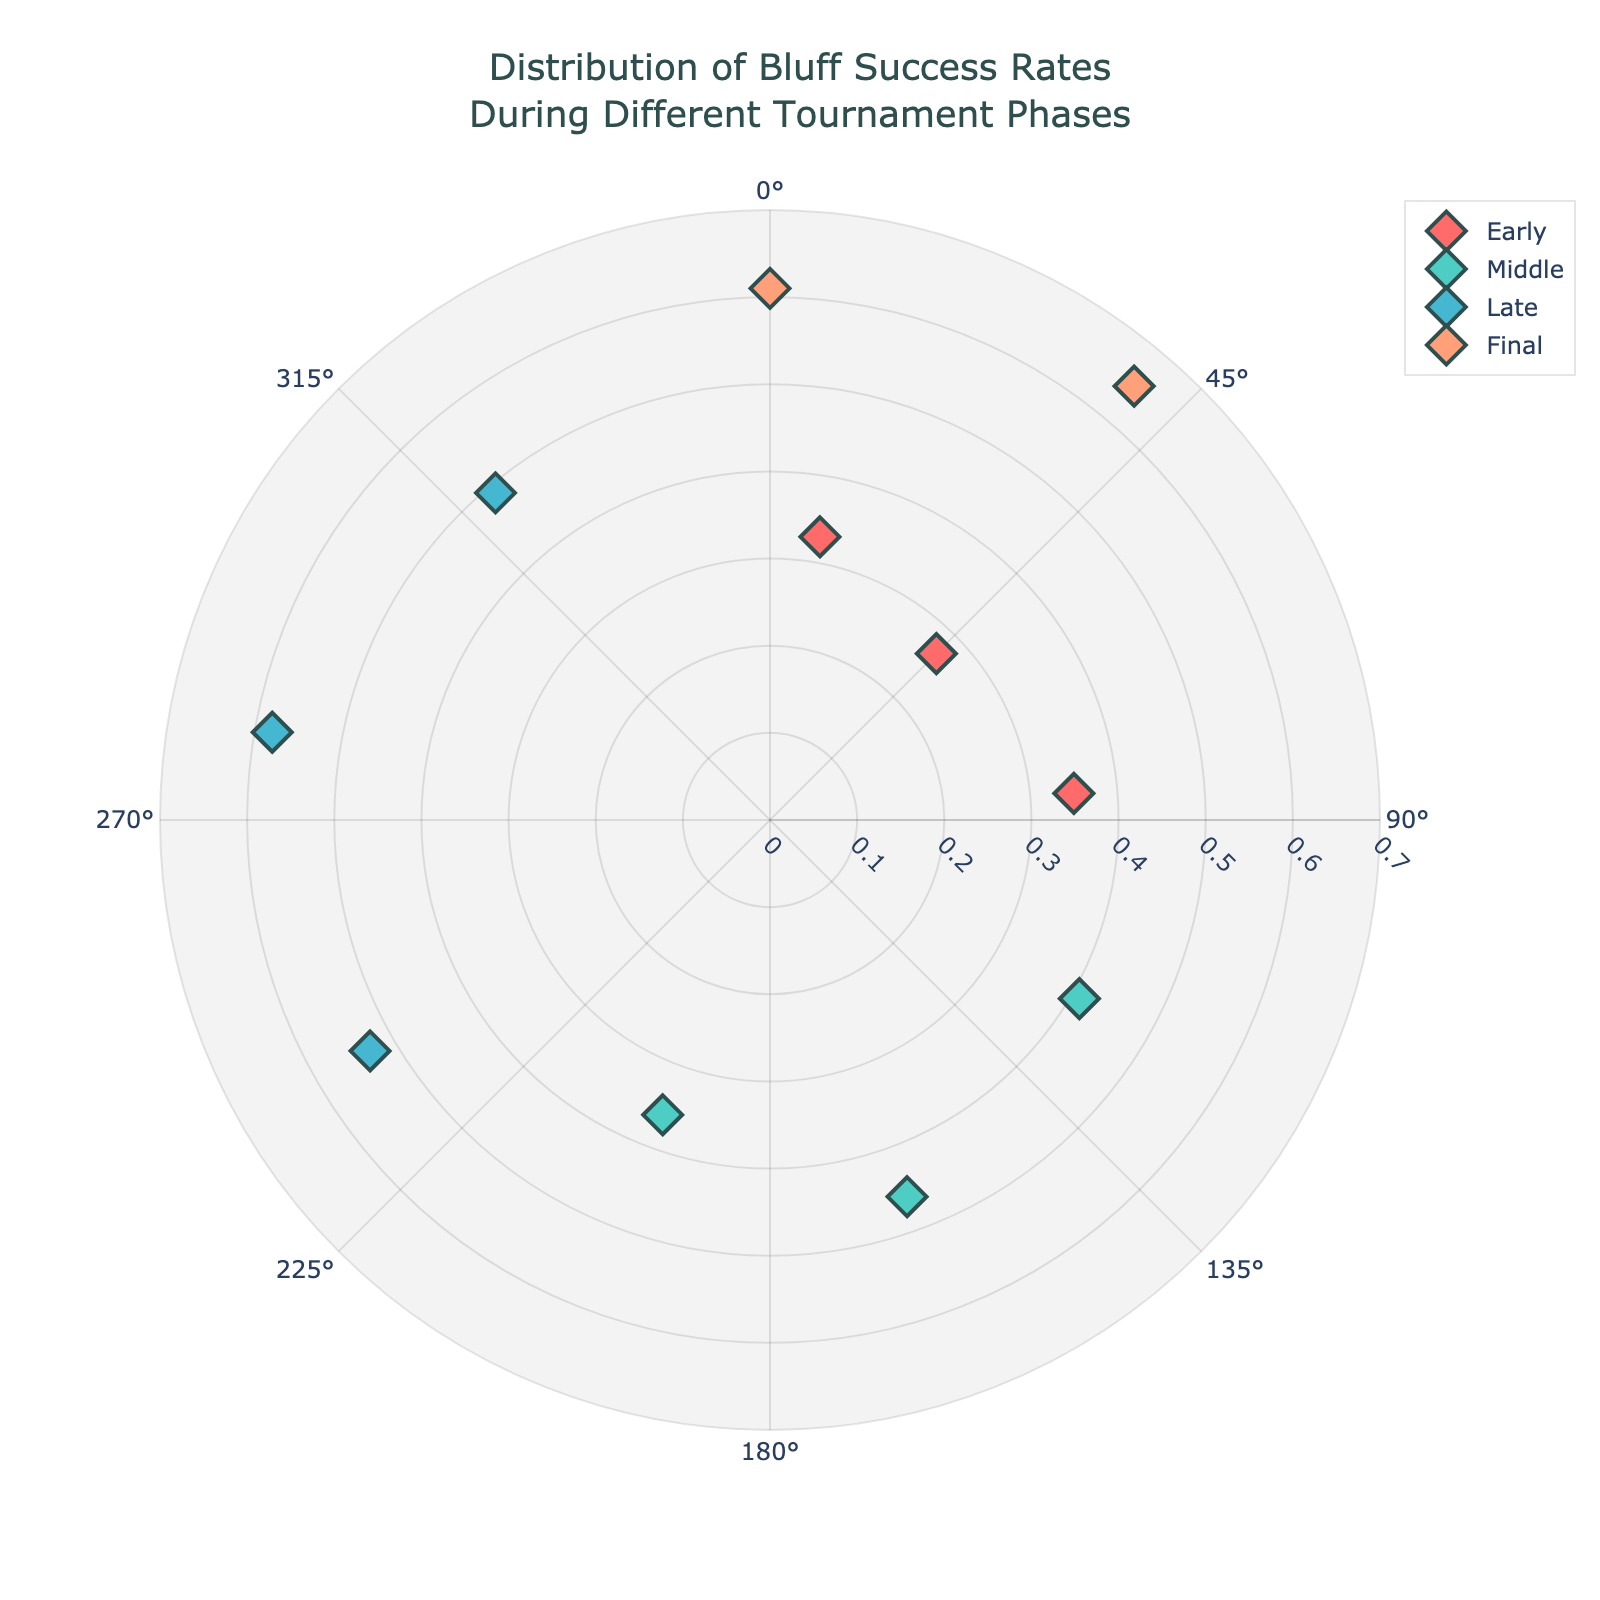what is the title of the chart? The title is located at the top of the chart and reads "Distribution of Bluff Success Rates During Different Tournament Phases".
Answer: Distribution of Bluff Success Rates During Different Tournament Phases how many different tournament phases are shown in the chart? By observing the legend on the chart, we see there are four distinct tournament phases indicated: Early, Middle, Late, and Final.
Answer: 4 which tournament phase has the highest bluff success rate? To determine the highest bluff success rate, we look at the furthest points from the center. The phase labeled "Final" has the most distant point from the center at a success rate of 0.65.
Answer: Final what is the range of bluff angles for the Early phase? By looking at the Early phase points, their positions on the angular axis go from 10 degrees to 85 degrees, giving us the range.
Answer: 10 to 85 degrees what is the average bluff success rate for the Middle phase? Calculate the average by summing the Middle phase success rates (0.41, 0.46, 0.36) and dividing by 3: (0.41 + 0.46 + 0.36) / 3 = 1.23 / 3 = 0.41.
Answer: 0.41 compare the bluff success rates in the Late phase with the Early phase. Which has overall higher success rates? The bluff success rates for the Late phase are 0.53, 0.58, and 0.49. The Early phase rates are 0.33, 0.27, and 0.35. The average rate for Late is (0.53 + 0.58 + 0.49) / 3 = 0.53. The average for Early is (0.33 + 0.27 + 0.35) / 3 = 0.32. Thus, the Late phase has overall higher rates.
Answer: Late phase what is the difference in bluff success rate between the highest point in the Final phase and the highest point in the Early phase? The highest point in the Final phase is 0.65, and in the Early phase, it's 0.35. The difference is 0.65 - 0.35 = 0.30.
Answer: 0.30 what color represents the Middle phase? By referring to the legend or the points in the Middle phase, we see they are colored using a shade of turquoise-greenish color.
Answer: Turquoise-greenish which phase has the most dispersed angles on the polar chart? Check which phase covers a broader angular range. Final phase spans from near 360 degrees to 400 degrees, giving it a range of 40 degrees. Comparatively, other phases have narrower ranges.
Answer: Final phase what's the median bluff success rate for the Late phase? Sort the Late phase success rates (0.49, 0.53, 0.58). The median is the value in the middle, which is 0.53.
Answer: 0.53 